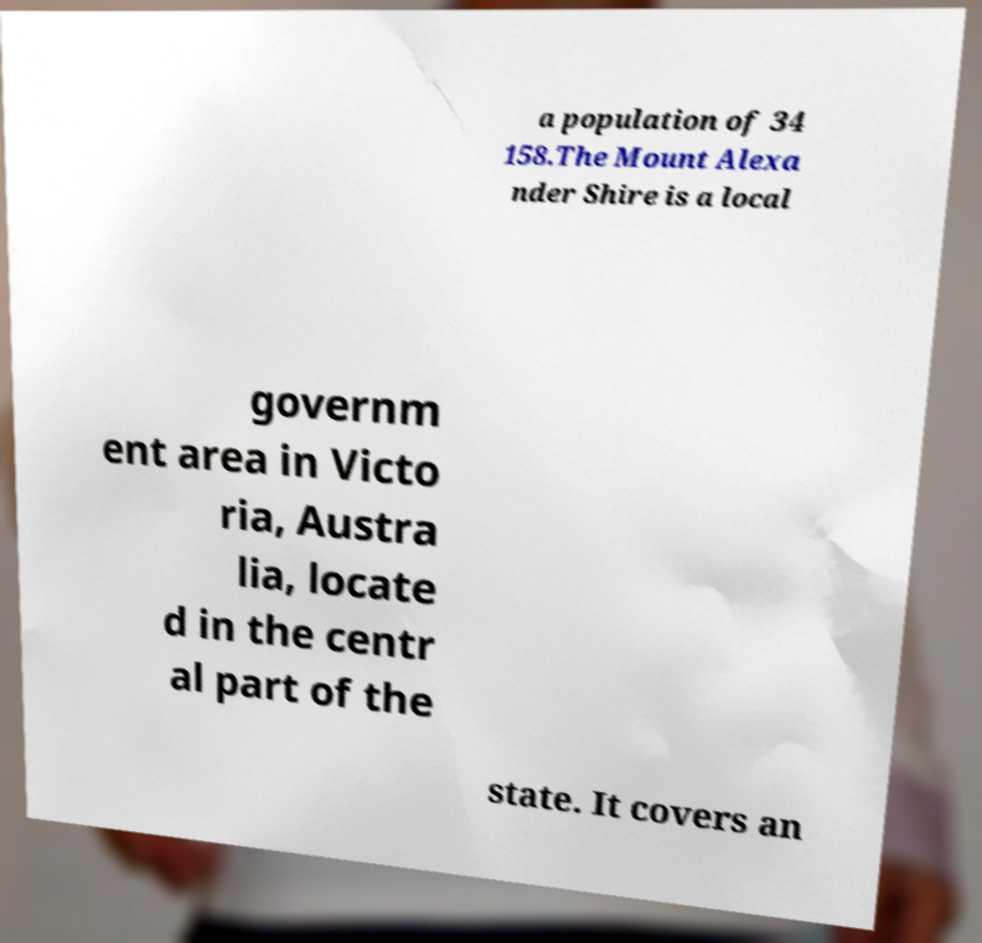Please read and relay the text visible in this image. What does it say? a population of 34 158.The Mount Alexa nder Shire is a local governm ent area in Victo ria, Austra lia, locate d in the centr al part of the state. It covers an 